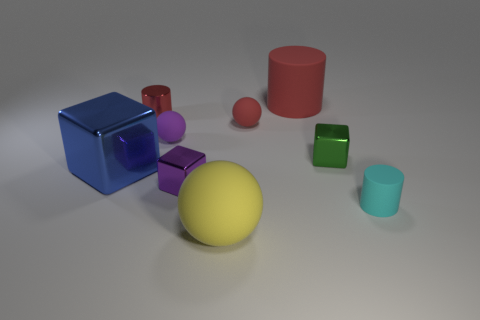Do the big matte ball and the large metallic block have the same color?
Your response must be concise. No. There is another purple thing that is the same shape as the big metallic thing; what is it made of?
Offer a terse response. Metal. What number of red objects are tiny cylinders or tiny shiny cylinders?
Ensure brevity in your answer.  1. There is a tiny cylinder right of the green shiny cube; what is it made of?
Offer a terse response. Rubber. Are there more large blue shiny objects than rubber spheres?
Provide a succinct answer. No. There is a large object behind the small purple ball; is it the same shape as the red shiny object?
Your response must be concise. Yes. How many things are both in front of the big blue shiny block and behind the tiny cyan rubber thing?
Give a very brief answer. 1. What number of other small shiny objects are the same shape as the small green shiny object?
Your response must be concise. 1. There is a big matte cylinder that is behind the block on the right side of the big red cylinder; what is its color?
Your response must be concise. Red. Is the shape of the tiny cyan matte object the same as the large matte object behind the tiny red sphere?
Your response must be concise. Yes. 